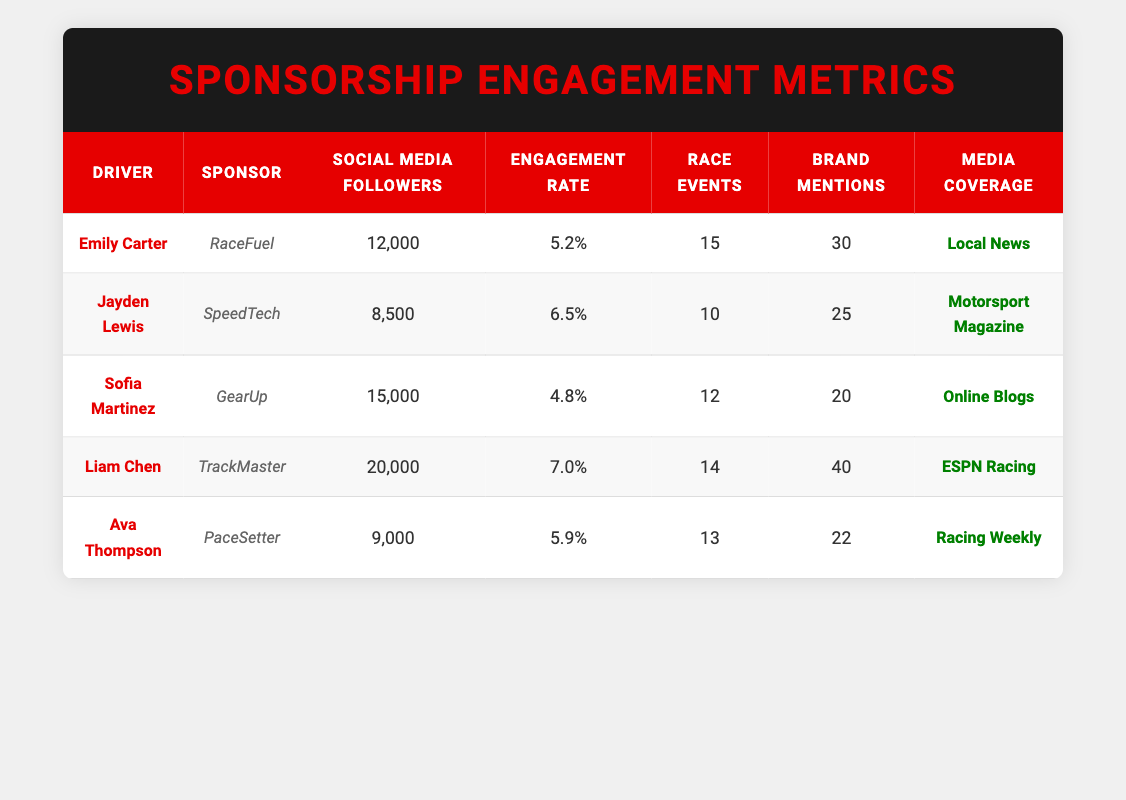What is the engagement rate for Liam Chen? According to the table, the engagement rate listed under Liam Chen's entry is 7.0%. This value can be directly retrieved from the table without needing to perform any calculations.
Answer: 7.0% How many social media followers does Ava Thompson have? From the table, Ava Thompson has 9,000 social media followers, as indicated in her row. This is a straightforward retrieval of the value in that specific cell.
Answer: 9,000 Which driver participated in the most race events and how many? By reviewing the race events participated column for all entries, Emily Carter appears with the highest number at 15 events. No other driver exceeds this number. This requires comparing the values across the relevant column.
Answer: Emily Carter, 15 What is the average number of brand mentions for all drivers? To find the average, we need to sum the brand mentions: (30 + 25 + 20 + 40 + 22) = 167. Then, we divide by the number of drivers (5), resulting in an average of 167 / 5 = 33.4. This requires both summing the values and then dividing by the total count of entries.
Answer: 33.4 Is Jayden Lewis's engagement rate higher than Sofia Martinez's? Jayden Lewis has an engagement rate of 6.5%, while Sofia Martinez has 4.8%. Since 6.5% is greater than 4.8%, this indicates that Jayden has a higher engagement rate. This is a simple comparison between the two specified values.
Answer: Yes Who has the lowest number of social media followers among the drivers? Looking through the social media followers column, Jayden Lewis has the lowest number at 8,500 followers. This involves comparing the values across the entire column to identify the minimum.
Answer: Jayden Lewis, 8,500 What total social media following do Liam Chen and Sofia Martinez have combined? Liam Chen has 20,000 followers and Sofia Martinez has 15,000 followers. Adding these together gives us a total of 20,000 + 15,000 = 35,000. This requires performing an addition operation on the two specified values.
Answer: 35,000 Was "Local News" the only media coverage for the drivers? By examining the media coverage column, multiple entries list different coverage sources: "Motorsport Magazine," "Online Blogs," "ESPN Racing," and "Racing Weekly" are noted alongside "Local News." This indicates that "Local News" is not the only media coverage in this dataset.
Answer: No Which sponsor has the highest brand mentions and how many? Upon reviewing the brand mentions column, Liam Chen appears with the highest count at 40 mentions. This requires comparing the brand mention counts across the rows to find the maximum value.
Answer: TrackMaster, 40 